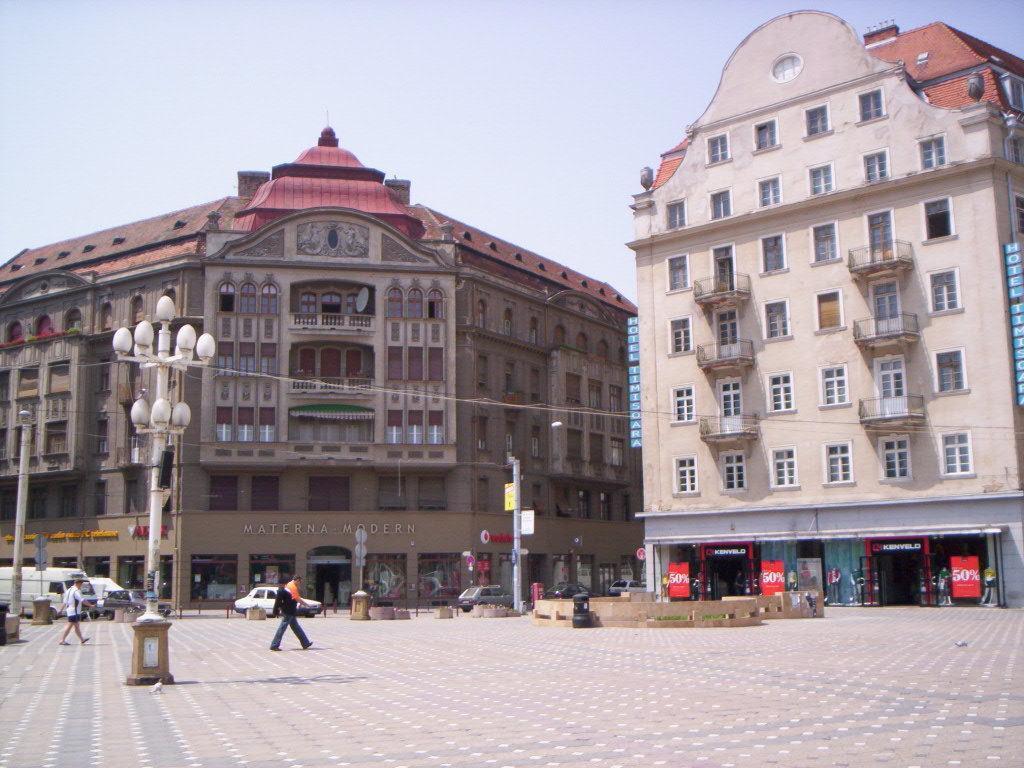Can you describe this image briefly? In this image there are some buildings and some stores, there are some people who are walking and also there are some vehicles, poles, lights and some boards. At the top of the image there is sky, and at the bottom there is a walkway. 